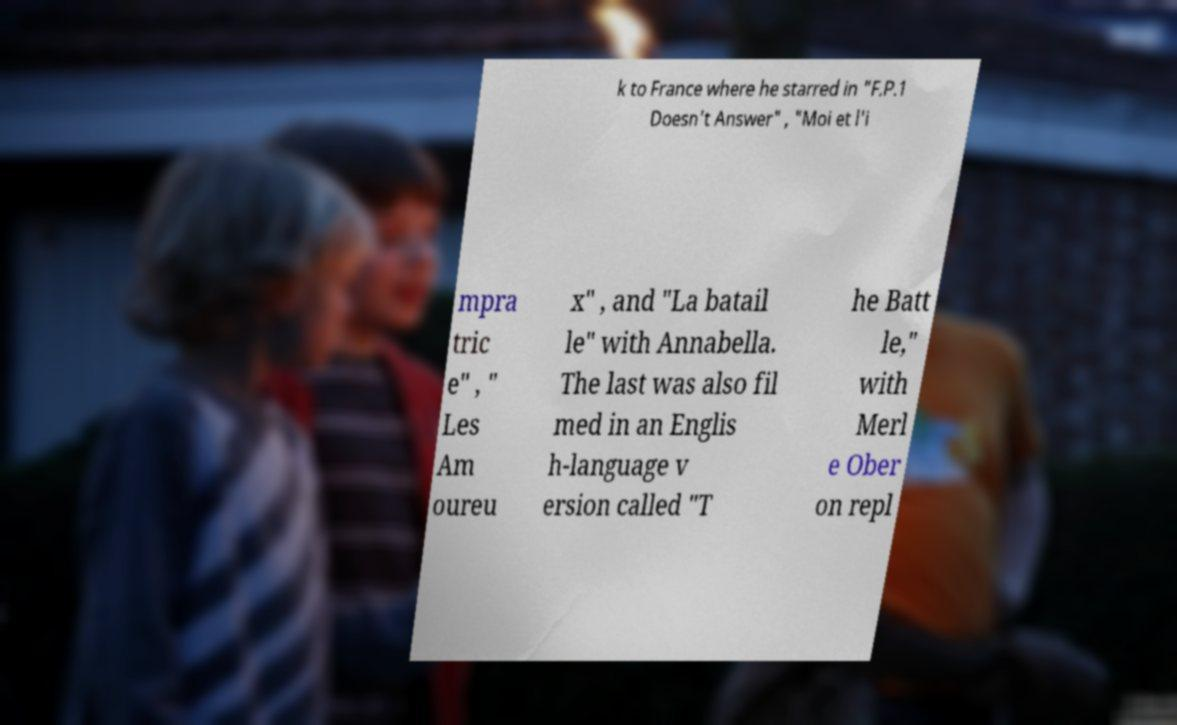Can you accurately transcribe the text from the provided image for me? k to France where he starred in "F.P.1 Doesn't Answer" , "Moi et l'i mpra tric e" , " Les Am oureu x" , and "La batail le" with Annabella. The last was also fil med in an Englis h-language v ersion called "T he Batt le," with Merl e Ober on repl 